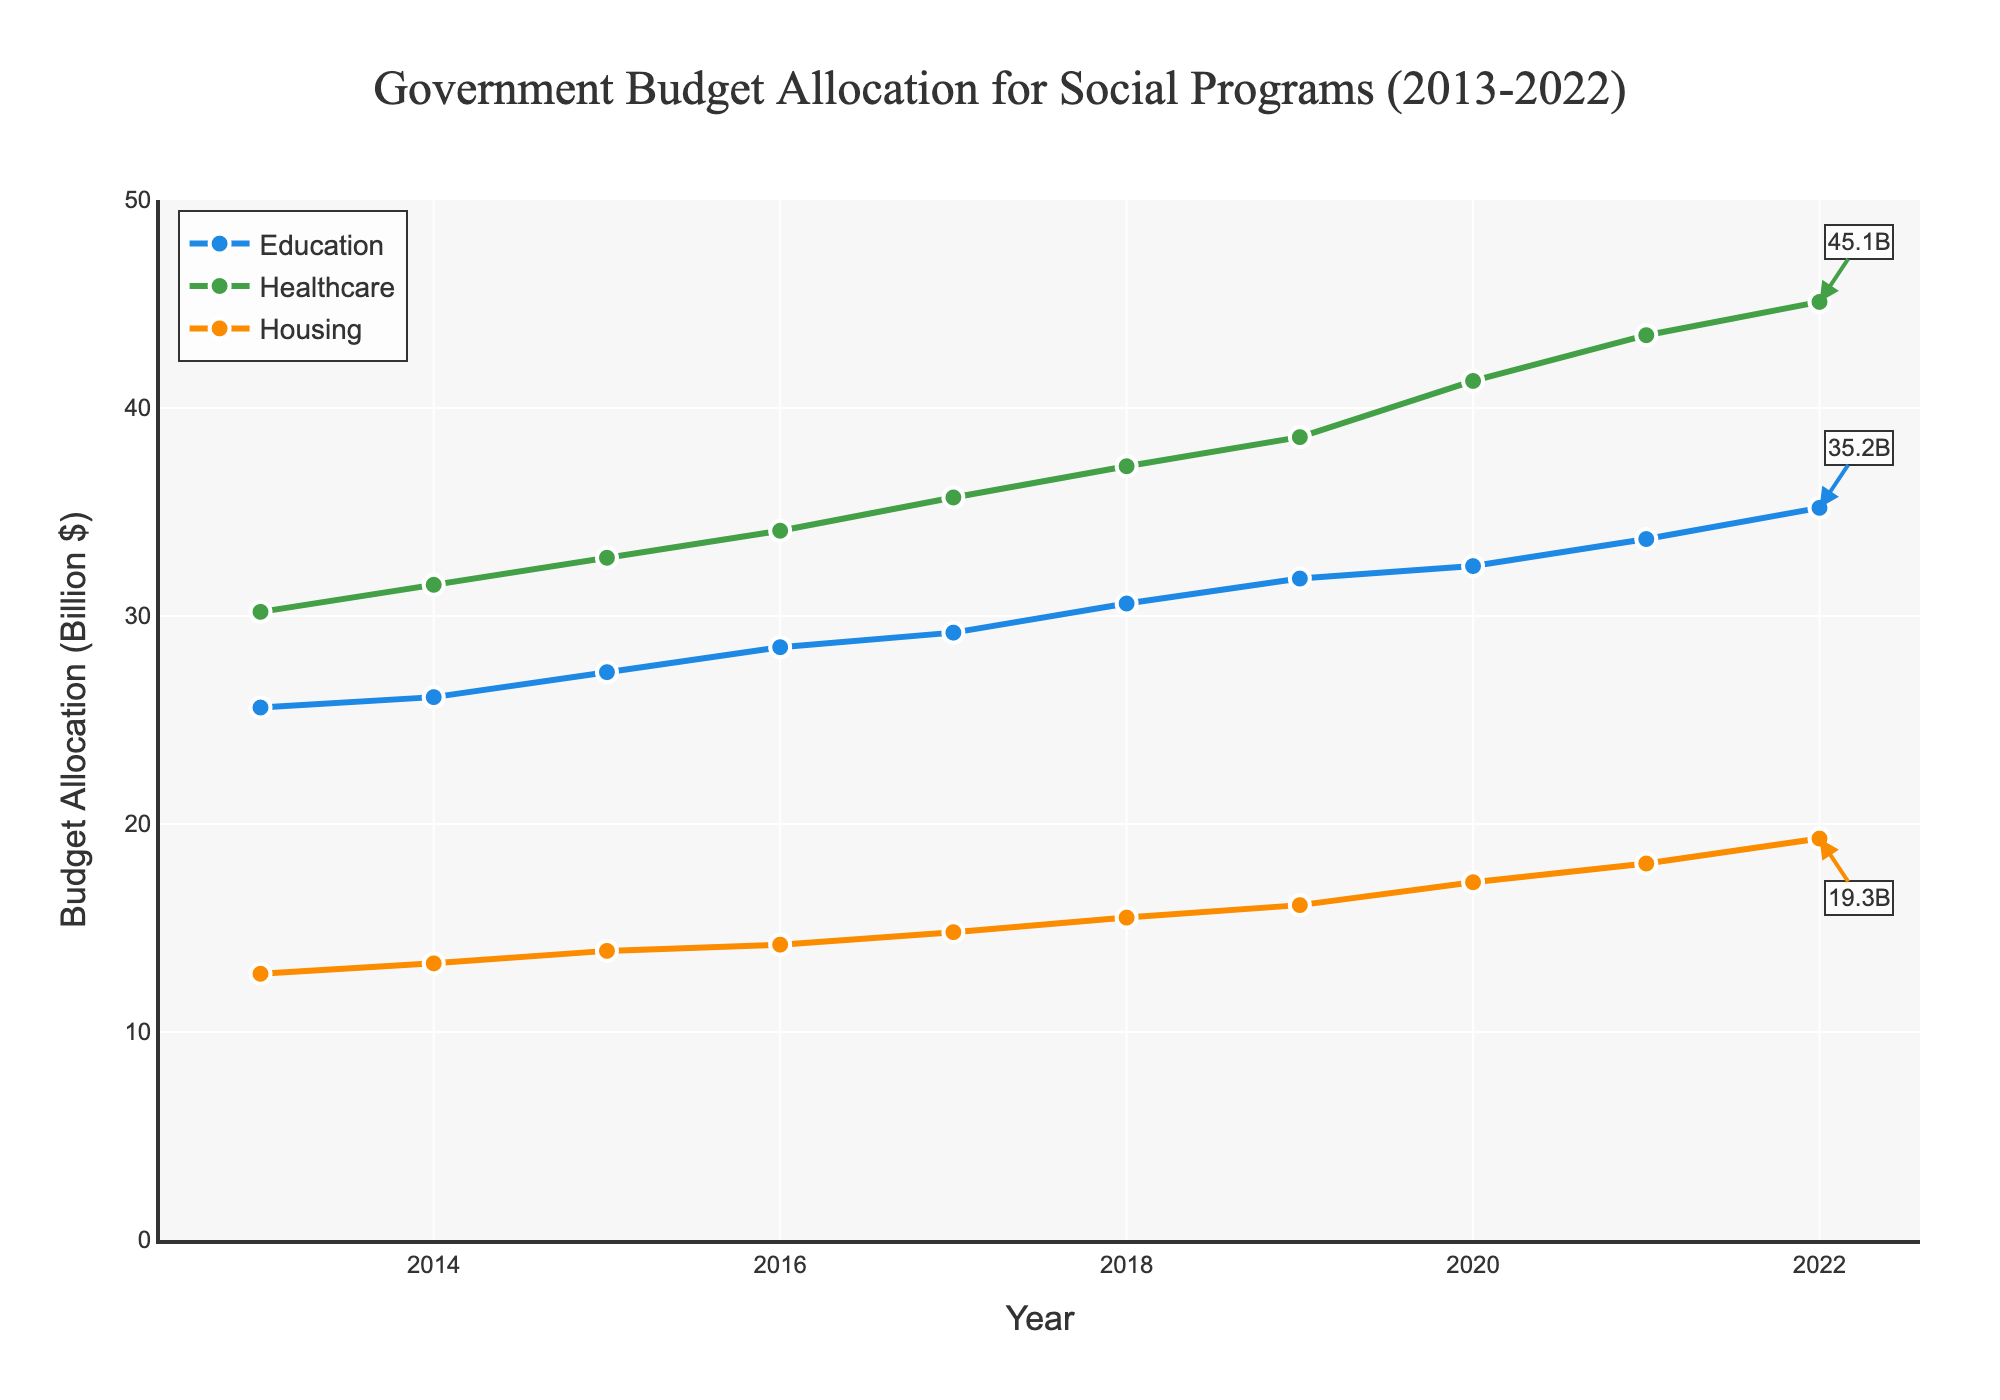What's the trend in the budget allocation for Education from 2013 to 2022? To determine the trend, observe the line for Education over the years. The line shows a consistent upward trajectory year by year.
Answer: Increasing How much did the Healthcare budget increase from 2013 to 2022? To calculate the increase, subtract the 2013 allocation from the 2022 allocation: 45.1 - 30.2 = 14.9 billion dollars.
Answer: 14.9 billion dollars Which sector had the most significant increase in budget allocation from 2013 to 2022? Compare the increases for each sector by subtracting the 2013 values from the 2022 values. Healthcare had the largest absolute increase (45.1 - 30.2 = 14.9 billion dollars).
Answer: Healthcare In what year did the Housing budget first exceed 15 billion dollars? Identify the year where Housing's value first exceeded 15 billion dollars. This occurred in 2018 when the allocation reached 15.5 billion dollars.
Answer: 2018 What was the combined budget allocation for Education and Housing in 2022? Add the 2022 values for Education and Housing: 35.2 + 19.3 = 54.5 billion dollars.
Answer: 54.5 billion dollars Did the Education budget always increase year over year? Observe the Education line in the plot to see if it consistently rises each year. Each year, the budget allocation for Education increased.
Answer: Yes Which sector saw the smallest increase in budget allocation from 2013 to 2022? Compare the increases by calculating the differences for each sector. Housing increased the least: 19.3 - 12.8 = 6.5 billion dollars.
Answer: Housing How did the Healthcare budget in 2022 compare with the combined Education and Housing budgets of 2013? Sum the budgets for Education and Housing in 2013 and compare it with Healthcare in 2022: 25.6 + 12.8 = 38.4 billion dollars, which is less than the Healthcare budget of 45.1 billion dollars in 2022.
Answer: Healthcare in 2022 was higher What percentage of the 2022 total budget for the three sectors was allocated to Healthcare? Sum the 2022 values for all three sectors, then calculate the percentage: (45.1 / (35.2 + 45.1 + 19.3)) * 100 = ~39.5%.
Answer: ~39.5% 